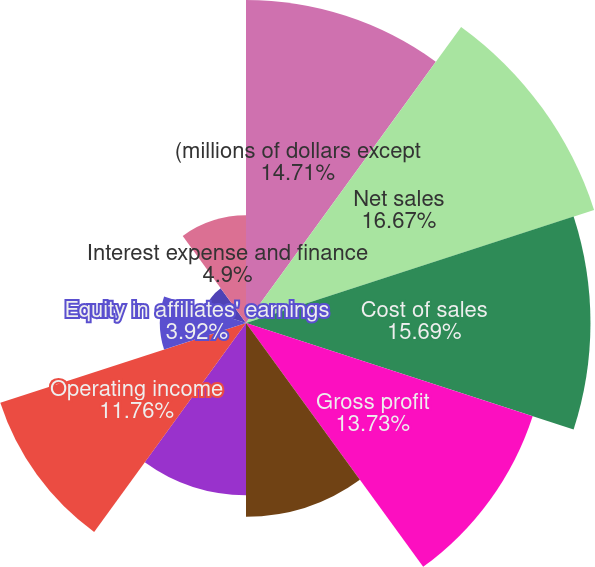<chart> <loc_0><loc_0><loc_500><loc_500><pie_chart><fcel>(millions of dollars except<fcel>Net sales<fcel>Cost of sales<fcel>Gross profit<fcel>Selling general and<fcel>Other expense (income) net<fcel>Operating income<fcel>Equity in affiliates' earnings<fcel>Interest income<fcel>Interest expense and finance<nl><fcel>14.7%<fcel>16.66%<fcel>15.68%<fcel>13.72%<fcel>8.82%<fcel>7.84%<fcel>11.76%<fcel>3.92%<fcel>1.96%<fcel>4.9%<nl></chart> 